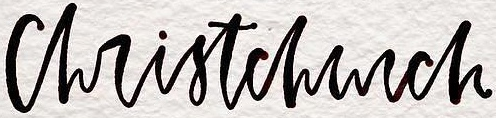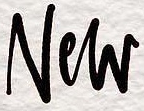Identify the words shown in these images in order, separated by a semicolon. christchurch; New 